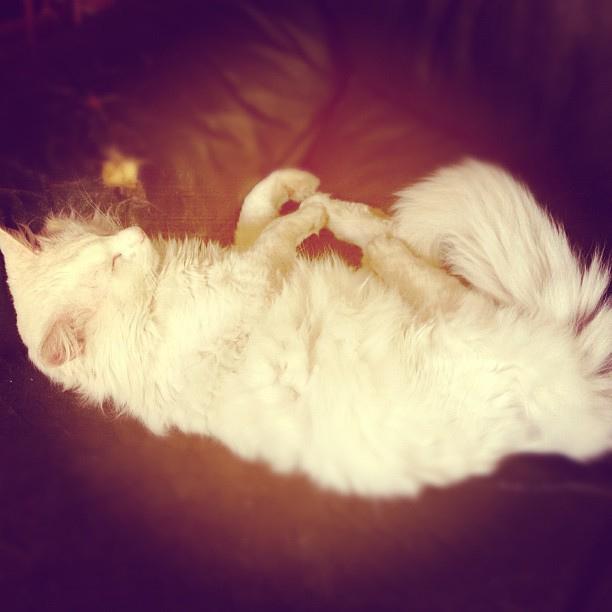Is the animal a rodent?
Answer briefly. No. Is the cat sleeping?
Give a very brief answer. Yes. Is the kitty asleep?
Answer briefly. Yes. Does this animal have fur or feathers?
Keep it brief. Fur. Does this animal bark?
Keep it brief. No. What color is the cat?
Quick response, please. White. What type of animal is this?
Quick response, please. Cat. 